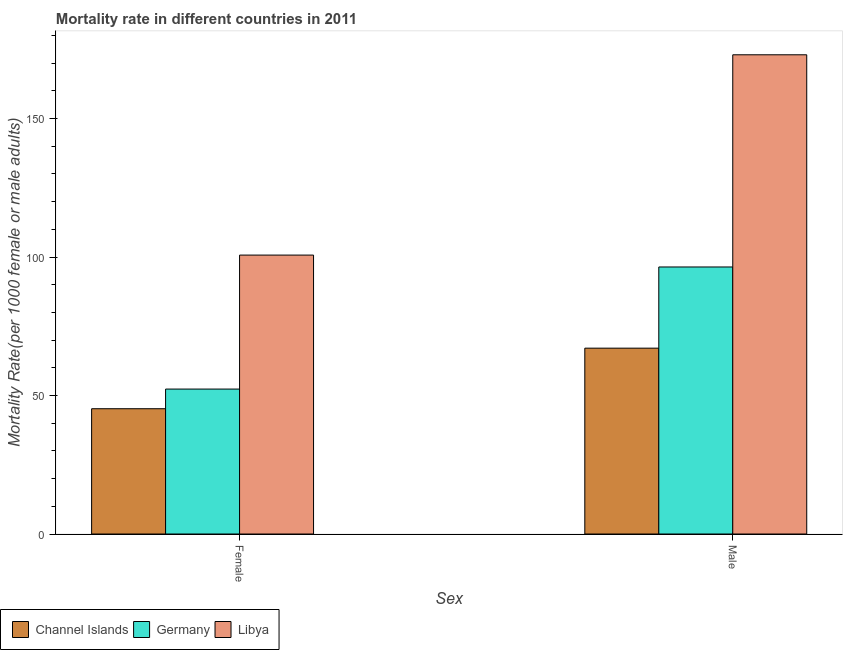How many different coloured bars are there?
Your answer should be compact. 3. How many groups of bars are there?
Provide a short and direct response. 2. Are the number of bars per tick equal to the number of legend labels?
Your answer should be compact. Yes. Are the number of bars on each tick of the X-axis equal?
Provide a short and direct response. Yes. How many bars are there on the 2nd tick from the right?
Your response must be concise. 3. What is the label of the 2nd group of bars from the left?
Ensure brevity in your answer.  Male. What is the male mortality rate in Germany?
Keep it short and to the point. 96.4. Across all countries, what is the maximum female mortality rate?
Give a very brief answer. 100.7. Across all countries, what is the minimum female mortality rate?
Make the answer very short. 45.23. In which country was the female mortality rate maximum?
Your response must be concise. Libya. In which country was the female mortality rate minimum?
Keep it short and to the point. Channel Islands. What is the total female mortality rate in the graph?
Offer a terse response. 198.25. What is the difference between the male mortality rate in Germany and that in Libya?
Provide a short and direct response. -76.6. What is the difference between the female mortality rate in Germany and the male mortality rate in Libya?
Offer a terse response. -120.68. What is the average female mortality rate per country?
Offer a terse response. 66.08. What is the difference between the female mortality rate and male mortality rate in Libya?
Keep it short and to the point. -72.31. In how many countries, is the male mortality rate greater than 80 ?
Keep it short and to the point. 2. What is the ratio of the female mortality rate in Channel Islands to that in Germany?
Give a very brief answer. 0.86. Is the male mortality rate in Germany less than that in Libya?
Provide a succinct answer. Yes. What does the 3rd bar from the left in Male represents?
Offer a very short reply. Libya. What does the 2nd bar from the right in Male represents?
Provide a short and direct response. Germany. Are all the bars in the graph horizontal?
Offer a terse response. No. Does the graph contain any zero values?
Your response must be concise. No. Where does the legend appear in the graph?
Offer a very short reply. Bottom left. How are the legend labels stacked?
Offer a terse response. Horizontal. What is the title of the graph?
Your answer should be very brief. Mortality rate in different countries in 2011. Does "Luxembourg" appear as one of the legend labels in the graph?
Your response must be concise. No. What is the label or title of the X-axis?
Ensure brevity in your answer.  Sex. What is the label or title of the Y-axis?
Offer a terse response. Mortality Rate(per 1000 female or male adults). What is the Mortality Rate(per 1000 female or male adults) of Channel Islands in Female?
Ensure brevity in your answer.  45.23. What is the Mortality Rate(per 1000 female or male adults) of Germany in Female?
Your answer should be very brief. 52.33. What is the Mortality Rate(per 1000 female or male adults) of Libya in Female?
Offer a terse response. 100.7. What is the Mortality Rate(per 1000 female or male adults) in Channel Islands in Male?
Ensure brevity in your answer.  67.09. What is the Mortality Rate(per 1000 female or male adults) of Germany in Male?
Make the answer very short. 96.4. What is the Mortality Rate(per 1000 female or male adults) in Libya in Male?
Keep it short and to the point. 173.01. Across all Sex, what is the maximum Mortality Rate(per 1000 female or male adults) of Channel Islands?
Ensure brevity in your answer.  67.09. Across all Sex, what is the maximum Mortality Rate(per 1000 female or male adults) of Germany?
Give a very brief answer. 96.4. Across all Sex, what is the maximum Mortality Rate(per 1000 female or male adults) of Libya?
Offer a terse response. 173.01. Across all Sex, what is the minimum Mortality Rate(per 1000 female or male adults) of Channel Islands?
Your answer should be compact. 45.23. Across all Sex, what is the minimum Mortality Rate(per 1000 female or male adults) in Germany?
Your response must be concise. 52.33. Across all Sex, what is the minimum Mortality Rate(per 1000 female or male adults) in Libya?
Provide a succinct answer. 100.7. What is the total Mortality Rate(per 1000 female or male adults) of Channel Islands in the graph?
Offer a terse response. 112.32. What is the total Mortality Rate(per 1000 female or male adults) of Germany in the graph?
Your answer should be compact. 148.73. What is the total Mortality Rate(per 1000 female or male adults) in Libya in the graph?
Make the answer very short. 273.7. What is the difference between the Mortality Rate(per 1000 female or male adults) of Channel Islands in Female and that in Male?
Offer a very short reply. -21.87. What is the difference between the Mortality Rate(per 1000 female or male adults) in Germany in Female and that in Male?
Make the answer very short. -44.08. What is the difference between the Mortality Rate(per 1000 female or male adults) of Libya in Female and that in Male?
Provide a short and direct response. -72.31. What is the difference between the Mortality Rate(per 1000 female or male adults) in Channel Islands in Female and the Mortality Rate(per 1000 female or male adults) in Germany in Male?
Keep it short and to the point. -51.18. What is the difference between the Mortality Rate(per 1000 female or male adults) in Channel Islands in Female and the Mortality Rate(per 1000 female or male adults) in Libya in Male?
Your answer should be very brief. -127.78. What is the difference between the Mortality Rate(per 1000 female or male adults) in Germany in Female and the Mortality Rate(per 1000 female or male adults) in Libya in Male?
Your answer should be very brief. -120.68. What is the average Mortality Rate(per 1000 female or male adults) in Channel Islands per Sex?
Your answer should be compact. 56.16. What is the average Mortality Rate(per 1000 female or male adults) in Germany per Sex?
Provide a succinct answer. 74.36. What is the average Mortality Rate(per 1000 female or male adults) of Libya per Sex?
Provide a short and direct response. 136.85. What is the difference between the Mortality Rate(per 1000 female or male adults) of Channel Islands and Mortality Rate(per 1000 female or male adults) of Libya in Female?
Keep it short and to the point. -55.47. What is the difference between the Mortality Rate(per 1000 female or male adults) in Germany and Mortality Rate(per 1000 female or male adults) in Libya in Female?
Ensure brevity in your answer.  -48.37. What is the difference between the Mortality Rate(per 1000 female or male adults) in Channel Islands and Mortality Rate(per 1000 female or male adults) in Germany in Male?
Make the answer very short. -29.31. What is the difference between the Mortality Rate(per 1000 female or male adults) of Channel Islands and Mortality Rate(per 1000 female or male adults) of Libya in Male?
Ensure brevity in your answer.  -105.91. What is the difference between the Mortality Rate(per 1000 female or male adults) in Germany and Mortality Rate(per 1000 female or male adults) in Libya in Male?
Provide a succinct answer. -76.6. What is the ratio of the Mortality Rate(per 1000 female or male adults) of Channel Islands in Female to that in Male?
Keep it short and to the point. 0.67. What is the ratio of the Mortality Rate(per 1000 female or male adults) in Germany in Female to that in Male?
Offer a very short reply. 0.54. What is the ratio of the Mortality Rate(per 1000 female or male adults) in Libya in Female to that in Male?
Provide a succinct answer. 0.58. What is the difference between the highest and the second highest Mortality Rate(per 1000 female or male adults) in Channel Islands?
Make the answer very short. 21.87. What is the difference between the highest and the second highest Mortality Rate(per 1000 female or male adults) of Germany?
Offer a very short reply. 44.08. What is the difference between the highest and the second highest Mortality Rate(per 1000 female or male adults) in Libya?
Offer a very short reply. 72.31. What is the difference between the highest and the lowest Mortality Rate(per 1000 female or male adults) of Channel Islands?
Keep it short and to the point. 21.87. What is the difference between the highest and the lowest Mortality Rate(per 1000 female or male adults) of Germany?
Make the answer very short. 44.08. What is the difference between the highest and the lowest Mortality Rate(per 1000 female or male adults) of Libya?
Make the answer very short. 72.31. 